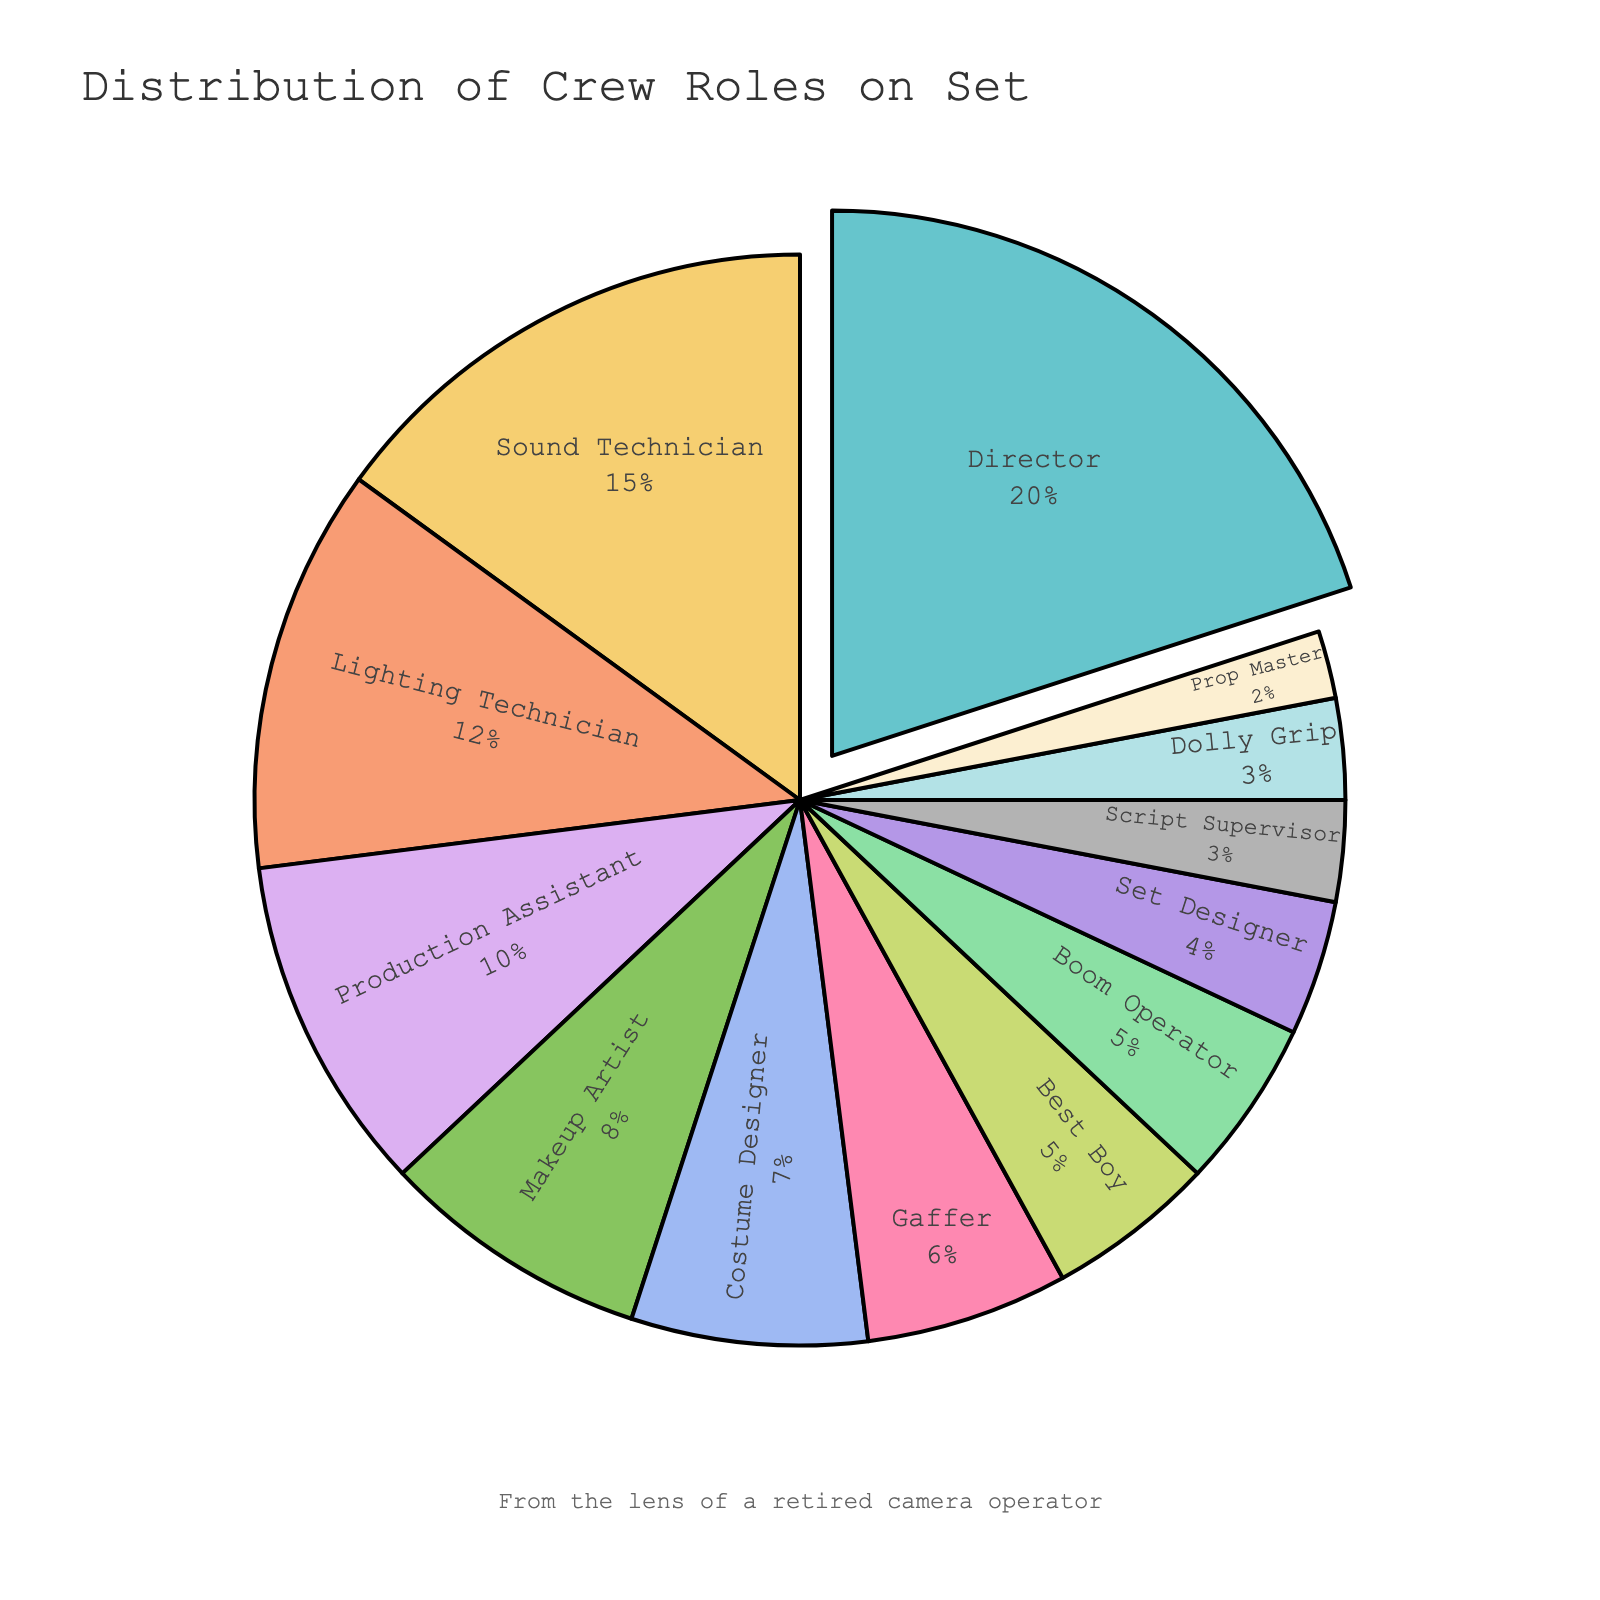What's the largest role in the crew distribution? By examining the slices of the pie chart, the 'Director' section is the largest, taking up 20% of the distribution.
Answer: Director What's the combined percentage of 'Boom Operator' and 'Prop Master'? Summing the percentages from the 'Boom Operator' (5%) and 'Prop Master' (2%) sections, we get 5% + 2% = 7%.
Answer: 7% Which role is more common on set, 'Lighting Technician' or 'Makeup Artist'? Comparing the sizes of the sections, 'Lighting Technician' at 12% is larger than 'Makeup Artist' at 8%.
Answer: Lighting Technician What is the sum of the percentages for 'Director', 'Sound Technician', and 'Production Assistant'? Adding the individual percentages of 'Director' (20%), 'Sound Technician' (15%), and 'Production Assistant' (10%) gives us 20% + 15% + 10% = 45%.
Answer: 45% Are there more 'Best Boys' or 'Set Designers' on set? By comparing the slices, 'Best Boy' has 5%, while 'Set Designer' has 4%. So 'Best Boy' is more common.
Answer: Best Boy What is the difference in percentages between the 'Gaffer' and the 'Costume Designer'? Gaffer's percentage is 6%, and Costume Designer's percentage is 7%. The difference is 7% - 6% = 1%.
Answer: 1% What fraction of the crew does the 'Dolly Grip' represent? The 'Dolly Grip' role takes up 3% of the crew.
Answer: 3% Which role has the smallest representation, and what is its percentage? The smallest slice belongs to the 'Prop Master' with 2%.
Answer: Prop Master at 2% Is the percentage of the 'Sound Technician' greater than that of the 'Lighting Technician'? Yes, the 'Sound Technician' has a percentage of 15%, and the 'Lighting Technician' has a percentage of 12%, so 15% > 12%.
Answer: Yes What visual cue highlights the largest segment in the pie chart? The largest segment representing the 'Director' is pulled slightly out from the center of the pie chart, making it visually distinct.
Answer: Segment is pulled out 